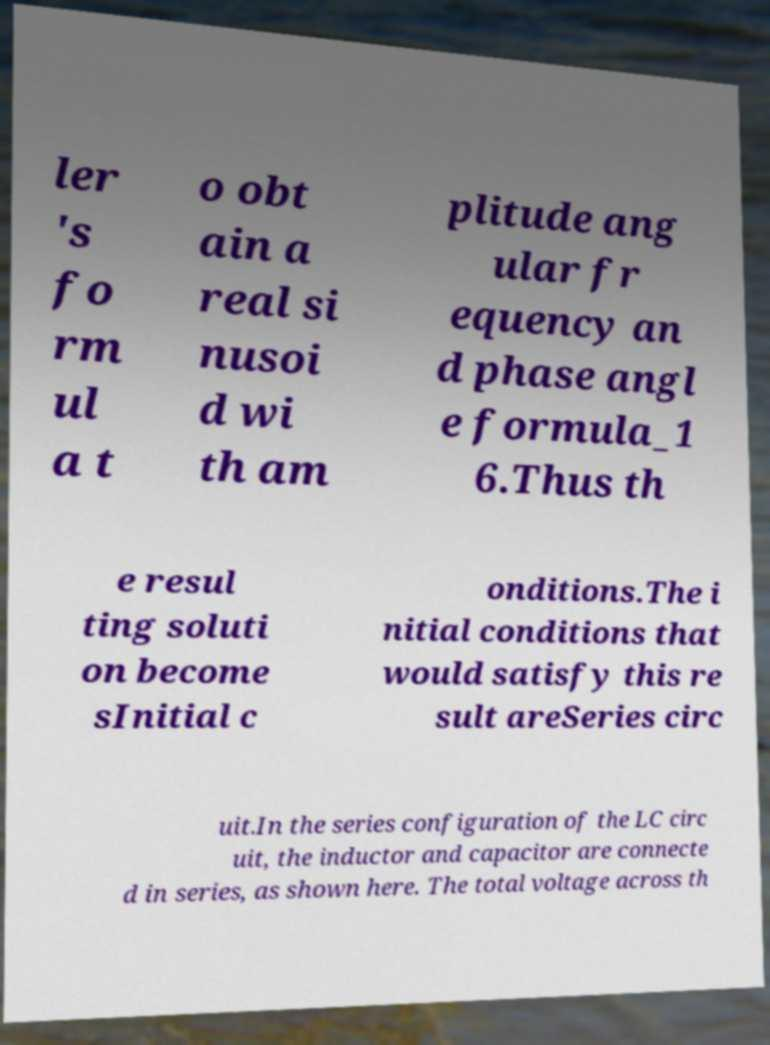Can you read and provide the text displayed in the image?This photo seems to have some interesting text. Can you extract and type it out for me? ler 's fo rm ul a t o obt ain a real si nusoi d wi th am plitude ang ular fr equency an d phase angl e formula_1 6.Thus th e resul ting soluti on become sInitial c onditions.The i nitial conditions that would satisfy this re sult areSeries circ uit.In the series configuration of the LC circ uit, the inductor and capacitor are connecte d in series, as shown here. The total voltage across th 